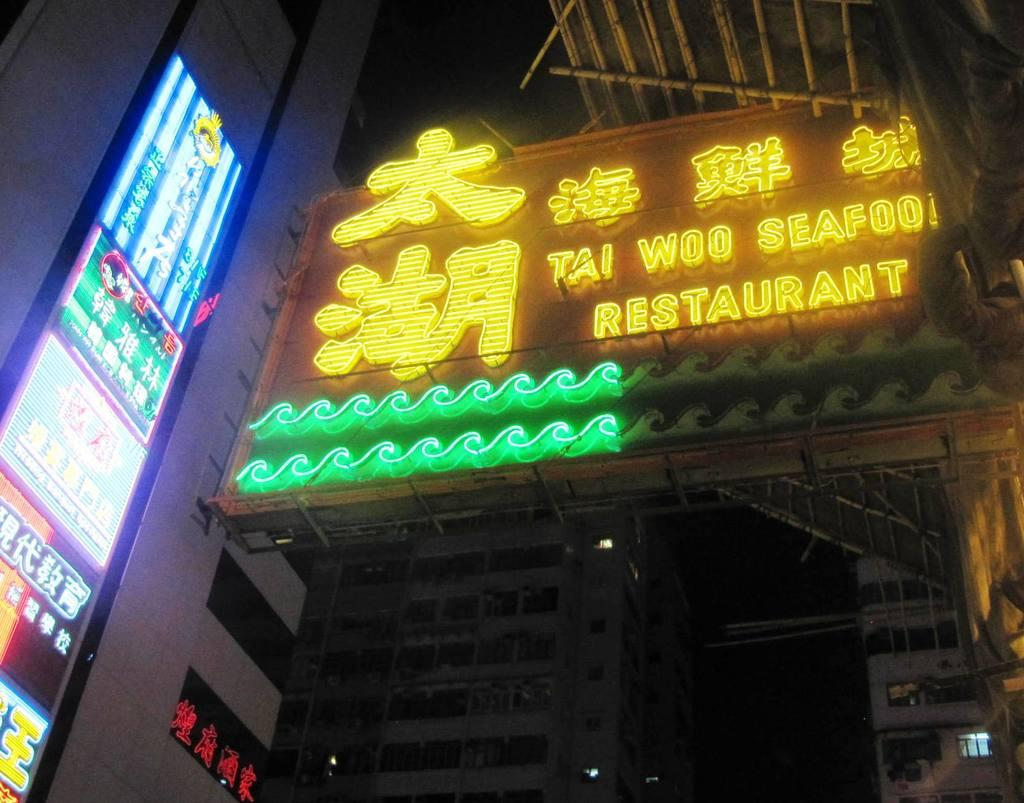What is the main object in the image? There is a restaurant board in the image. Where is the restaurant board located? The restaurant board is attached to a building. What feature does the restaurant board have? The restaurant board has lights. What can be seen in the background of the image? There are buildings with windows visible in the background of the image. How many cakes are displayed on the restaurant board in the image? There is no mention of cakes on the restaurant board in the image. The image only shows a restaurant board with lights attached to a building. 